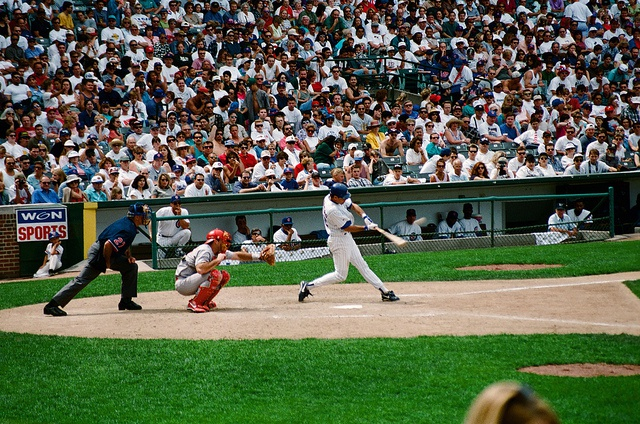Describe the objects in this image and their specific colors. I can see people in gray, black, maroon, lightgray, and darkgray tones, people in gray, darkgray, lightgray, and black tones, people in gray, maroon, and lightgray tones, people in gray, black, and blue tones, and people in gray, white, brown, darkgray, and black tones in this image. 